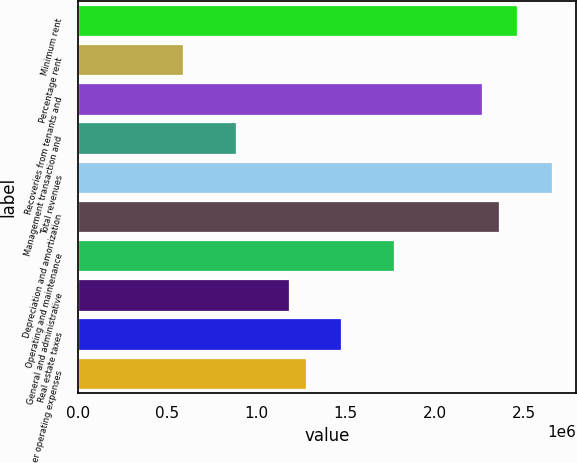<chart> <loc_0><loc_0><loc_500><loc_500><bar_chart><fcel>Minimum rent<fcel>Percentage rent<fcel>Recoveries from tenants and<fcel>Management transaction and<fcel>Total revenues<fcel>Depreciation and amortization<fcel>Operating and maintenance<fcel>General and administrative<fcel>Real estate taxes<fcel>Other operating expenses<nl><fcel>2.46081e+06<fcel>590596<fcel>2.26395e+06<fcel>885894<fcel>2.65768e+06<fcel>2.36238e+06<fcel>1.77179e+06<fcel>1.18119e+06<fcel>1.47649e+06<fcel>1.27962e+06<nl></chart> 